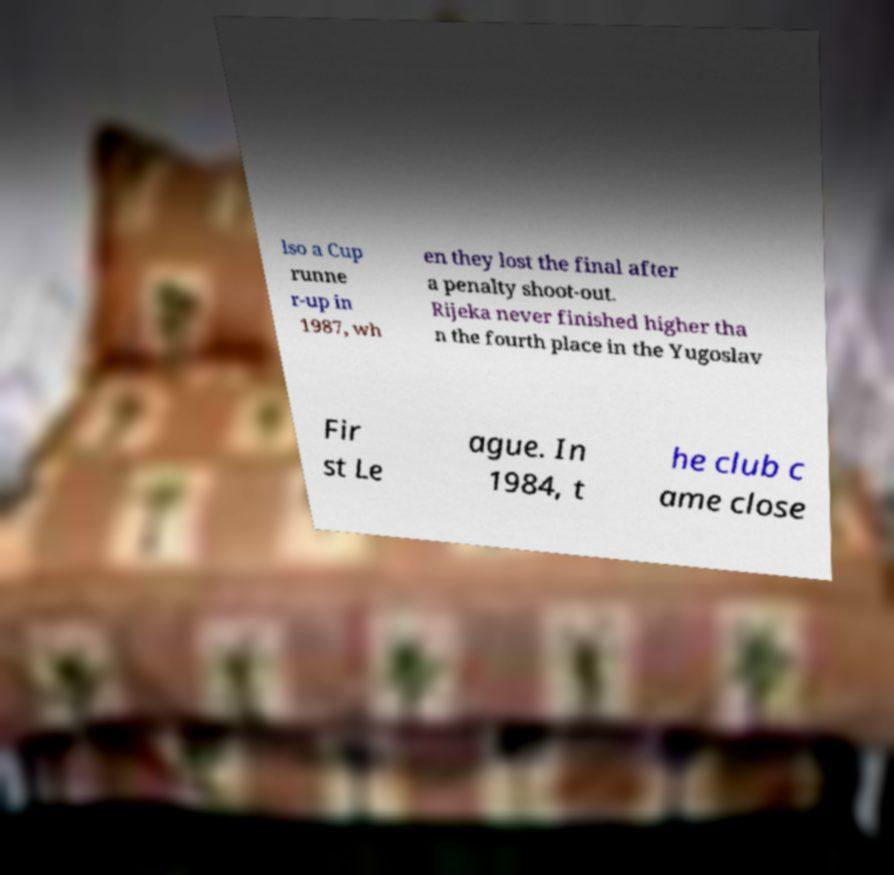Can you read and provide the text displayed in the image?This photo seems to have some interesting text. Can you extract and type it out for me? lso a Cup runne r-up in 1987, wh en they lost the final after a penalty shoot-out. Rijeka never finished higher tha n the fourth place in the Yugoslav Fir st Le ague. In 1984, t he club c ame close 